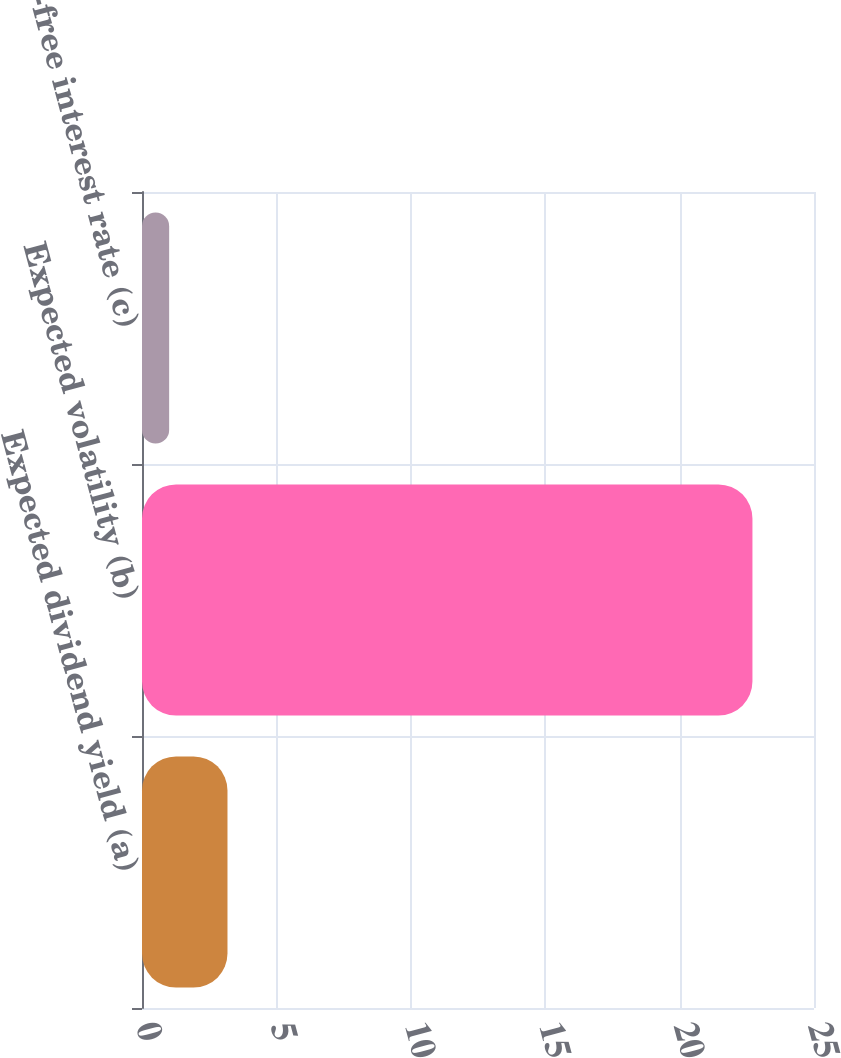<chart> <loc_0><loc_0><loc_500><loc_500><bar_chart><fcel>Expected dividend yield (a)<fcel>Expected volatility (b)<fcel>Risk-free interest rate (c)<nl><fcel>3.18<fcel>22.71<fcel>1.01<nl></chart> 